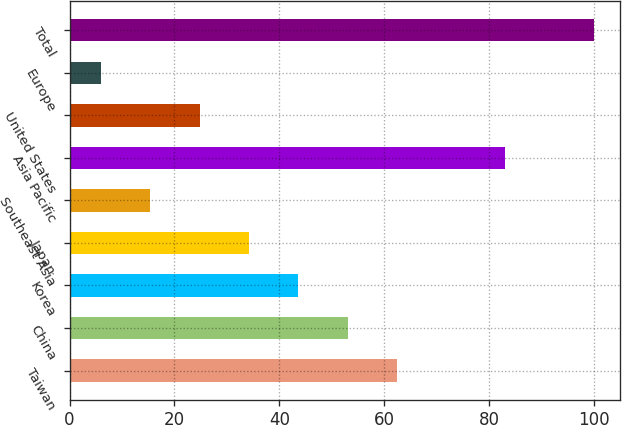Convert chart to OTSL. <chart><loc_0><loc_0><loc_500><loc_500><bar_chart><fcel>Taiwan<fcel>China<fcel>Korea<fcel>Japan<fcel>Southeast Asia<fcel>Asia Pacific<fcel>United States<fcel>Europe<fcel>Total<nl><fcel>62.4<fcel>53<fcel>43.6<fcel>34.2<fcel>15.4<fcel>83<fcel>24.8<fcel>6<fcel>100<nl></chart> 